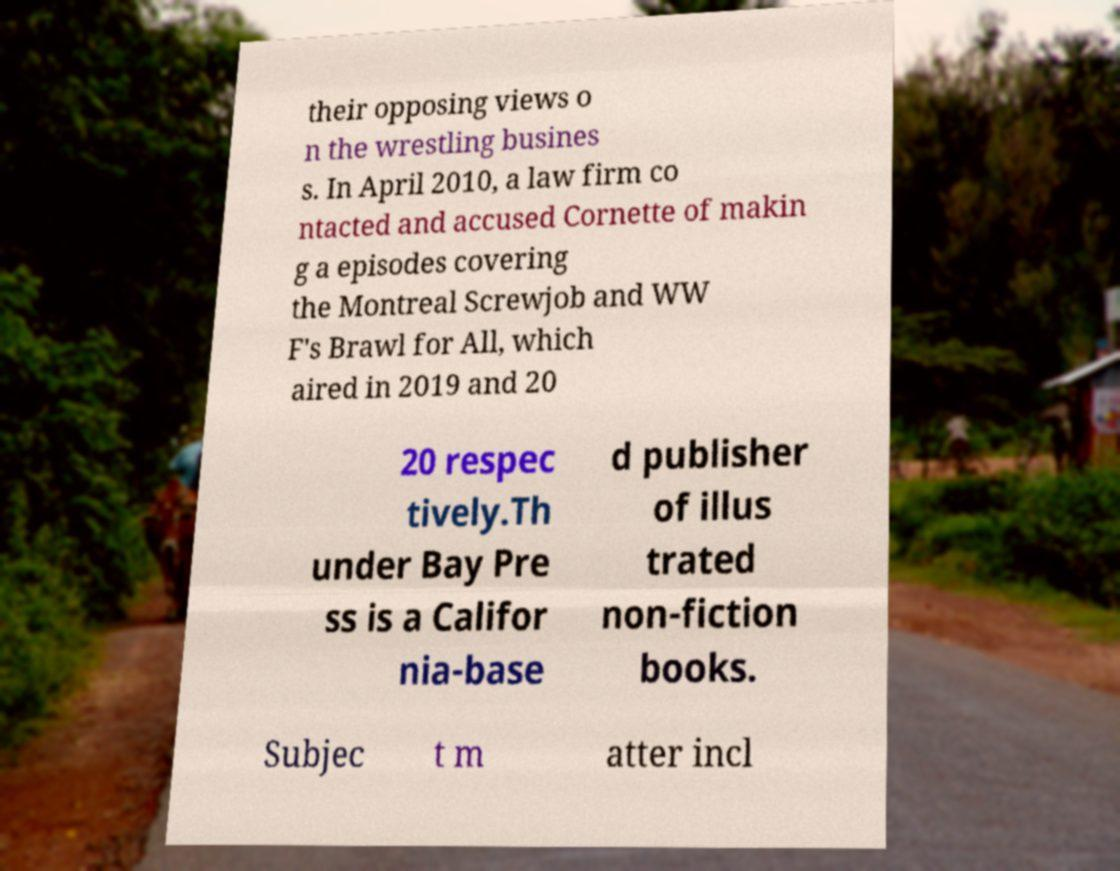Can you read and provide the text displayed in the image?This photo seems to have some interesting text. Can you extract and type it out for me? their opposing views o n the wrestling busines s. In April 2010, a law firm co ntacted and accused Cornette of makin g a episodes covering the Montreal Screwjob and WW F's Brawl for All, which aired in 2019 and 20 20 respec tively.Th under Bay Pre ss is a Califor nia-base d publisher of illus trated non-fiction books. Subjec t m atter incl 